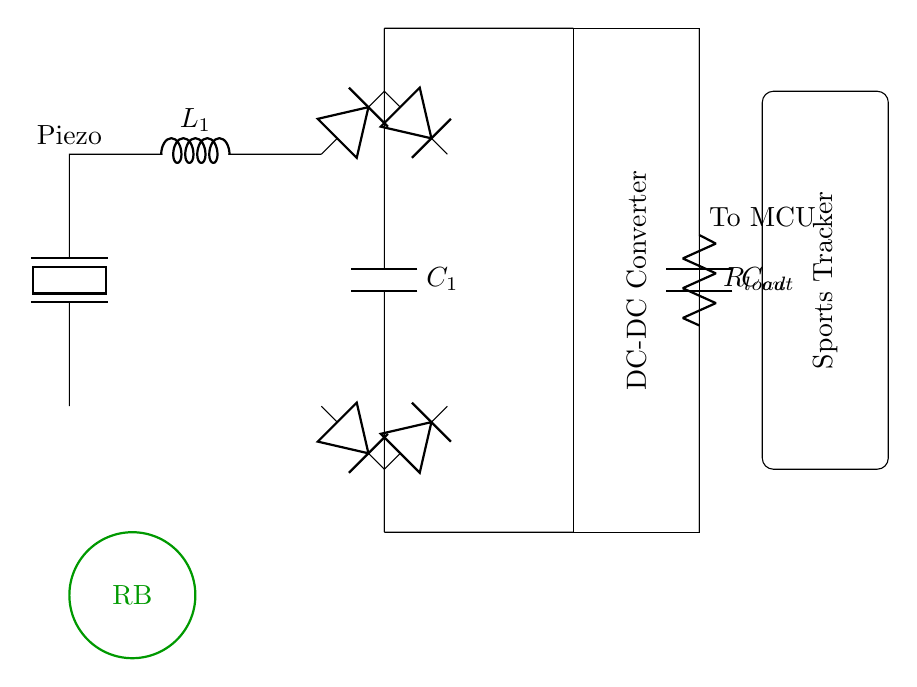What component converts mechanical energy to electrical energy? The piezoelectric element in the circuit is responsible for converting mechanical energy into electrical energy when it is stressed or deformed.
Answer: Piezoelectric element What does the smoothing capacitor do? The smoothing capacitor, labeled C1, helps to stabilize the output voltage from the rectifier bridge by reducing voltage ripple, providing a more constant DC output.
Answer: Stabilizes output voltage What is the function of the DC-DC converter in this circuit? The DC-DC converter adjusts the voltage level to a desired value suitable for the load, ensuring efficient power management and adaptation based on the output from the smoothing capacitor.
Answer: Adjusts voltage level What type of rectifier is used in this circuit? The circuit uses a full-wave rectifier, indicated by the arrangement of four diodes in a bridge configuration effectively converting AC voltage to DC voltage.
Answer: Full-wave rectifier What does the load resistor represent? The load resistor, labeled R_load, represents the component that consumes power from the circuit, simulating the load that the sports tracking device would typically present.
Answer: Loads the circuit Why are multiple diodes used in the rectifier section? Multiple diodes are used in the rectifier section to form a bridge configuration that allows the circuit to convert both halves of the AC waveform into a usable DC voltage, improving efficiency.
Answer: Converts both halves of AC How is energy stored in the circuit? Energy is stored in the output capacitor, labeled C_out, which accumulates charge from the rectified and smoothed voltage, providing power to the load when needed.
Answer: Stored in output capacitor 